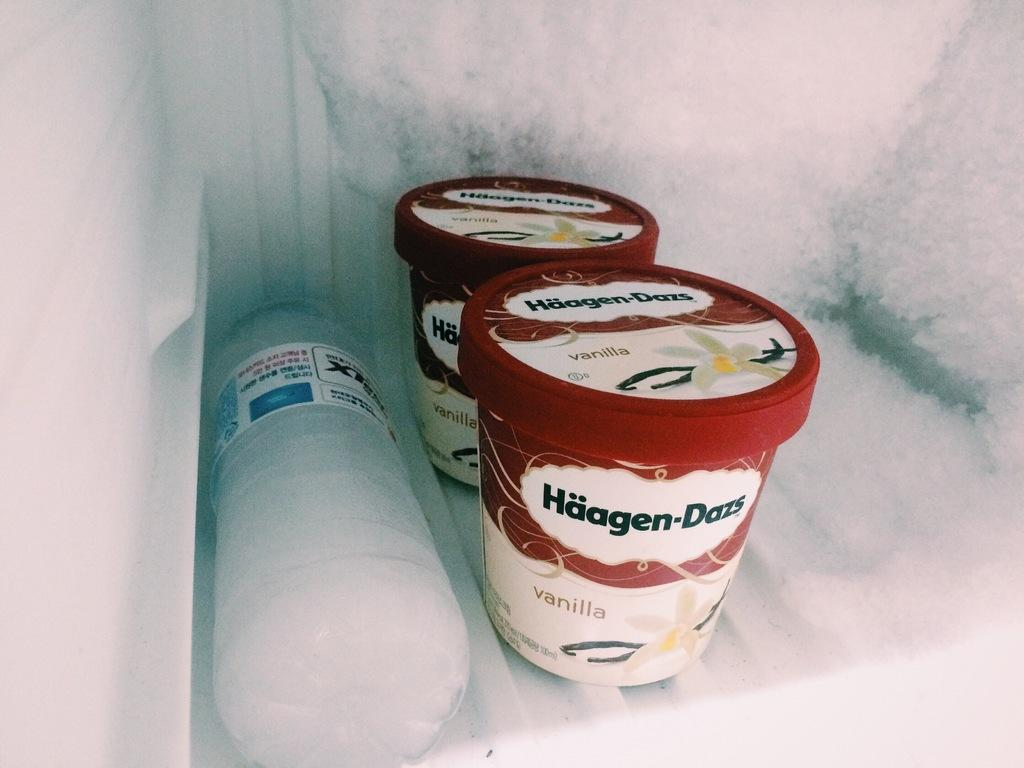What type of containers are visible in the image? There are plastic containers in the image. What other item can be seen in the image? There is a disposal bottle in the image. Where are the plastic containers and disposal bottle located? The plastic containers and disposal bottle are inside a freezer. How many quilts are stored in the freezer in the image? There are no quilts present in the image; it only contains plastic containers and a disposal bottle. 